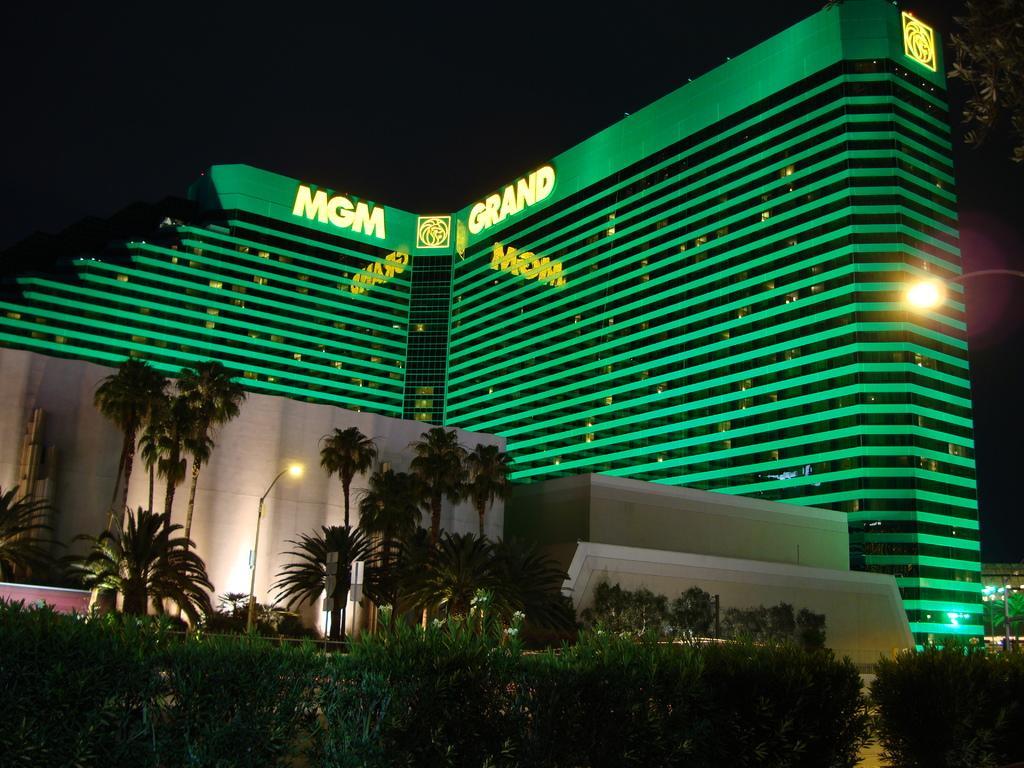Describe this image in one or two sentences. In this image there is a five-star hotel in the middle. At the bottom there are trees around the hotel. There is a street in the middle. At the top there is a symbol on the hotel. At the bottom there are plants. 